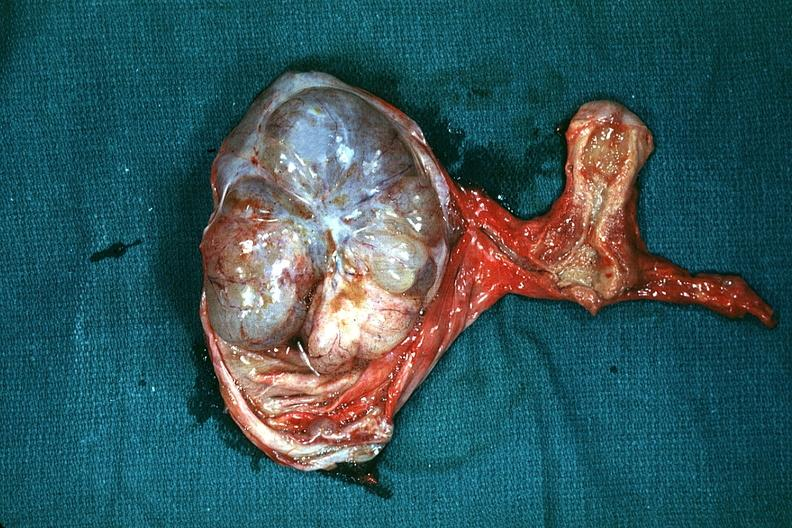how is the excellent uterus in picture and thus illustrates the very size of the ovarian tumor?
Answer the question using a single word or phrase. Large 